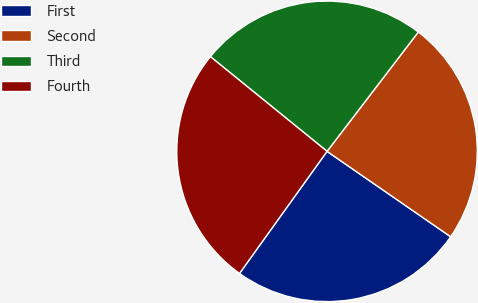Convert chart. <chart><loc_0><loc_0><loc_500><loc_500><pie_chart><fcel>First<fcel>Second<fcel>Third<fcel>Fourth<nl><fcel>25.28%<fcel>24.23%<fcel>24.54%<fcel>25.95%<nl></chart> 